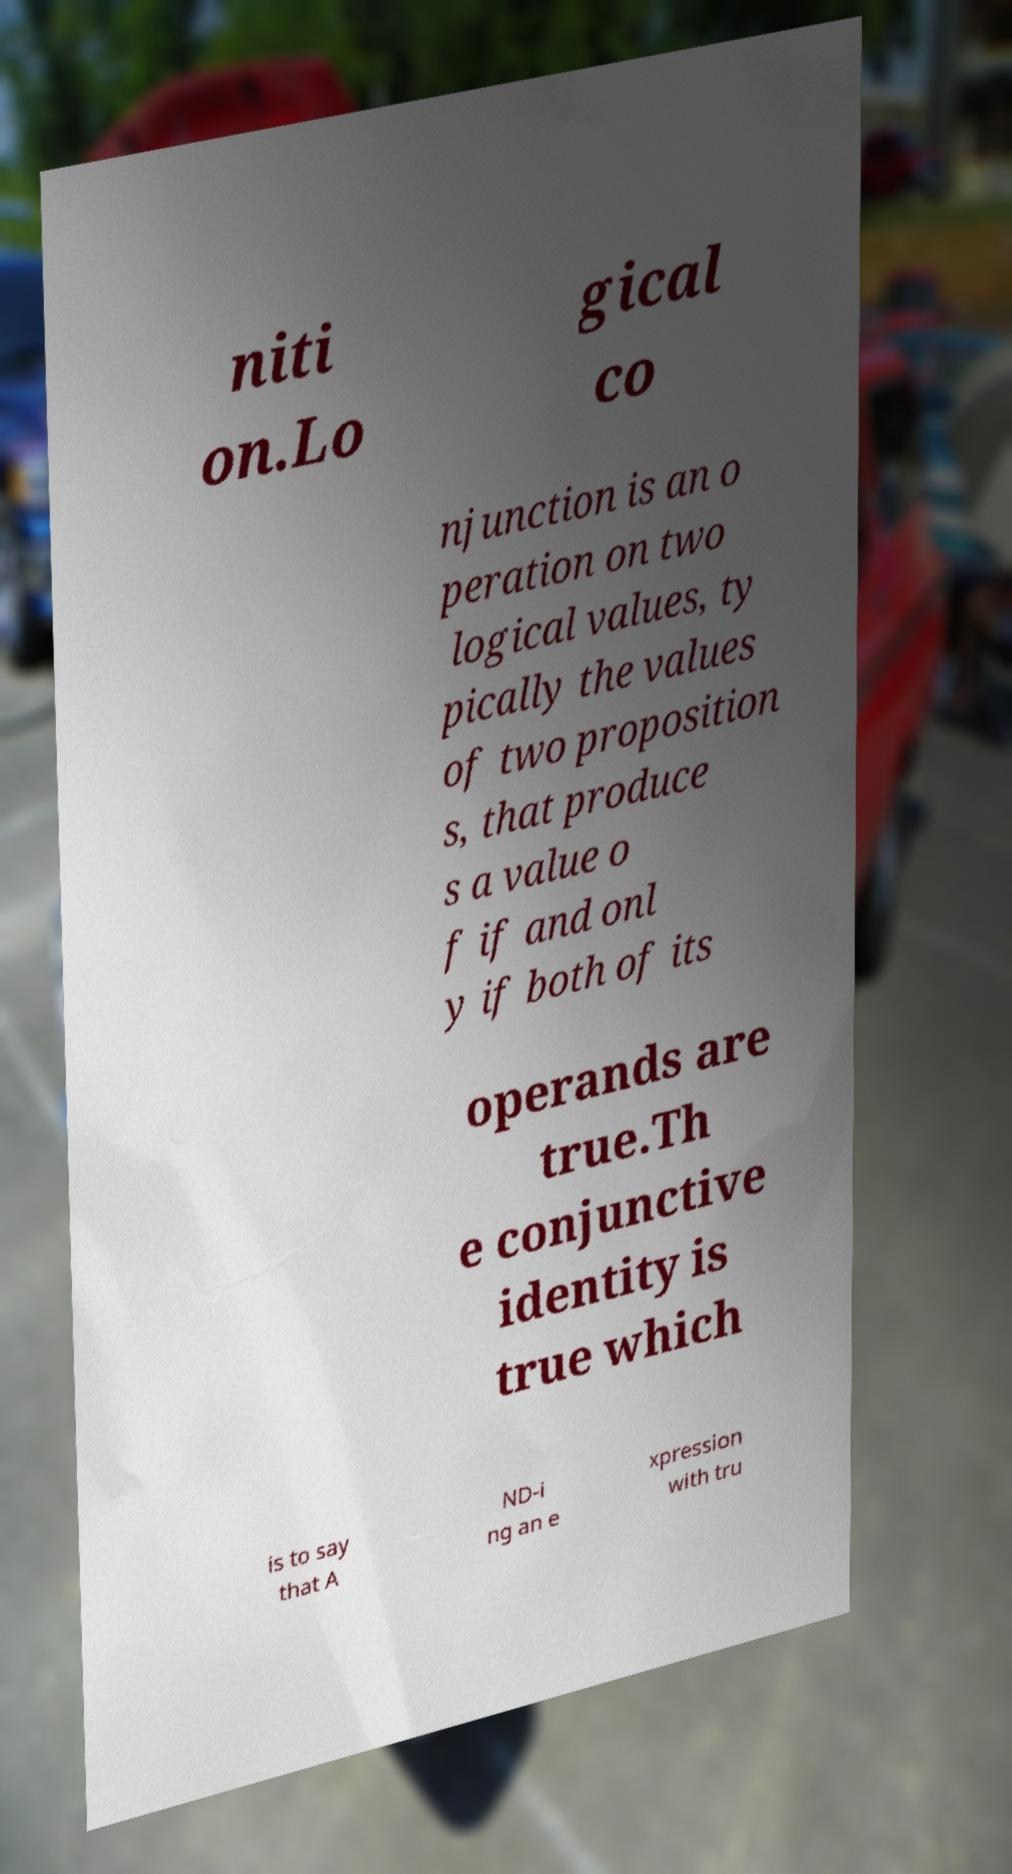I need the written content from this picture converted into text. Can you do that? niti on.Lo gical co njunction is an o peration on two logical values, ty pically the values of two proposition s, that produce s a value o f if and onl y if both of its operands are true.Th e conjunctive identity is true which is to say that A ND-i ng an e xpression with tru 